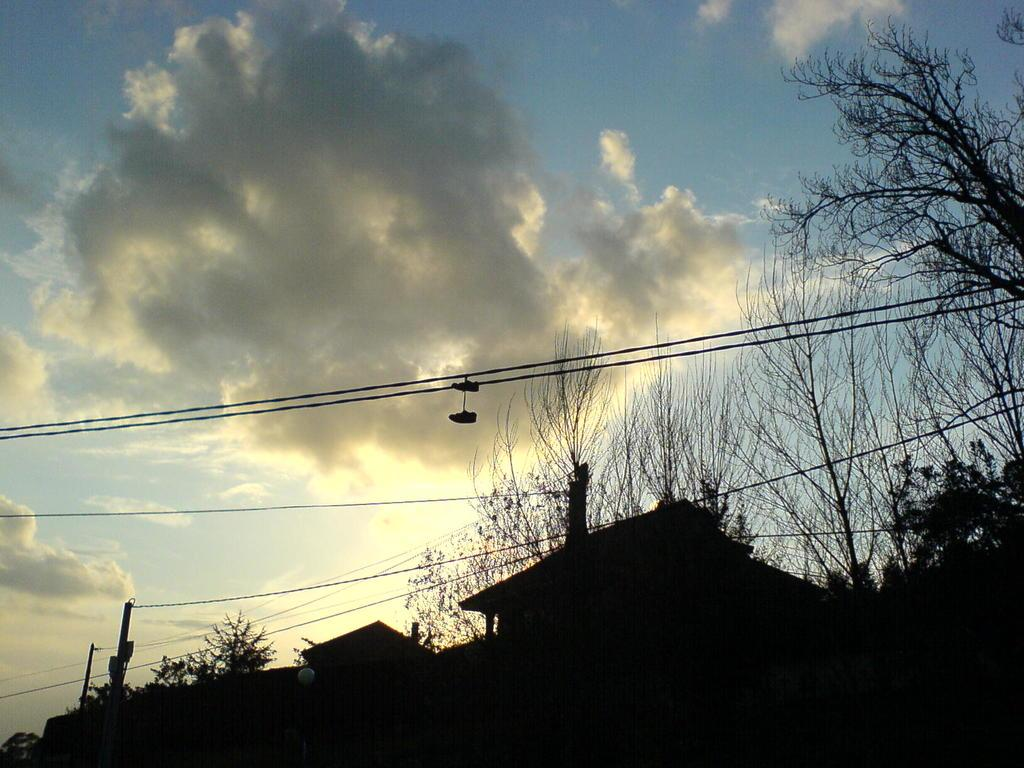What is visible at the top of the image? The sky is visible at the top of the image. What can be seen in the sky? Clouds are present in the sky. What objects are present in the center of the image? Houses and trees are present in the center of the image. What else can be seen in the image? There are electric wires in the image. How does the growth of the trees affect the print on the houses in the image? There is no print on the houses in the image, and the growth of the trees does not affect any print. What thought process can be observed in the image? There is no thought process visible in the image; it is a still image of houses, trees, clouds, and electric wires. 